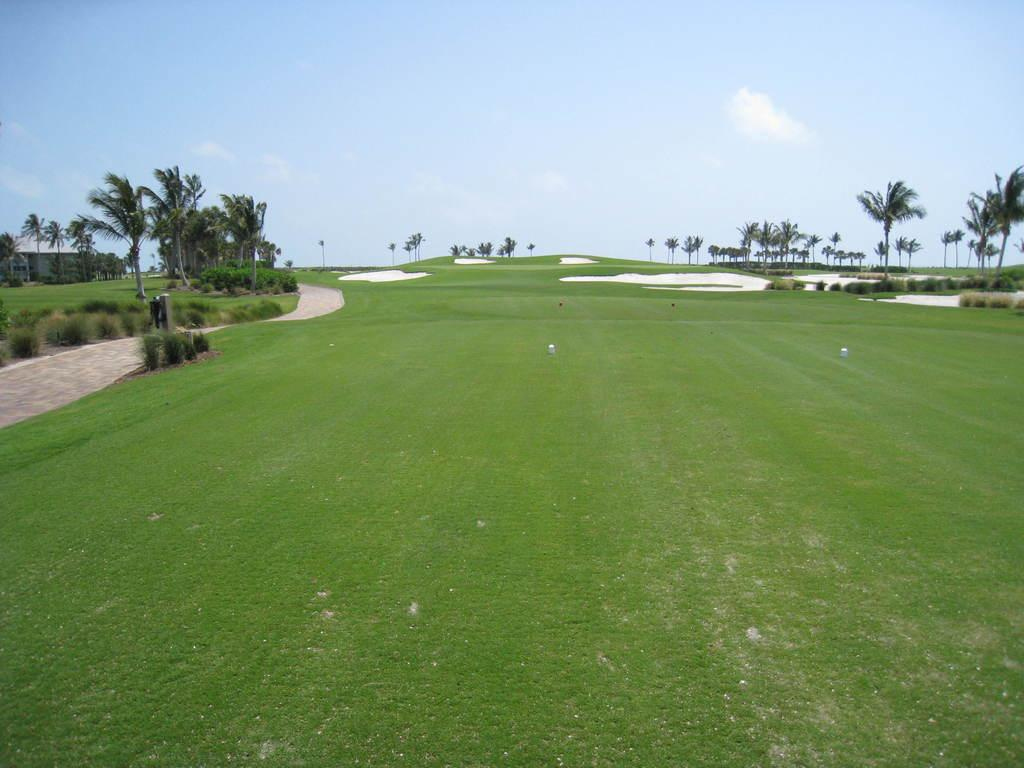What type of vegetation is present in the image? There is green grass and plants in the image. What can be seen in the background of the image? There are trees in the background of the image. What is visible in the sky in the image? The sky is clear and visible in the image. Where is the governor standing in the image? There is no governor present in the image. What type of quiver can be seen in the image? There is no quiver present in the image. 